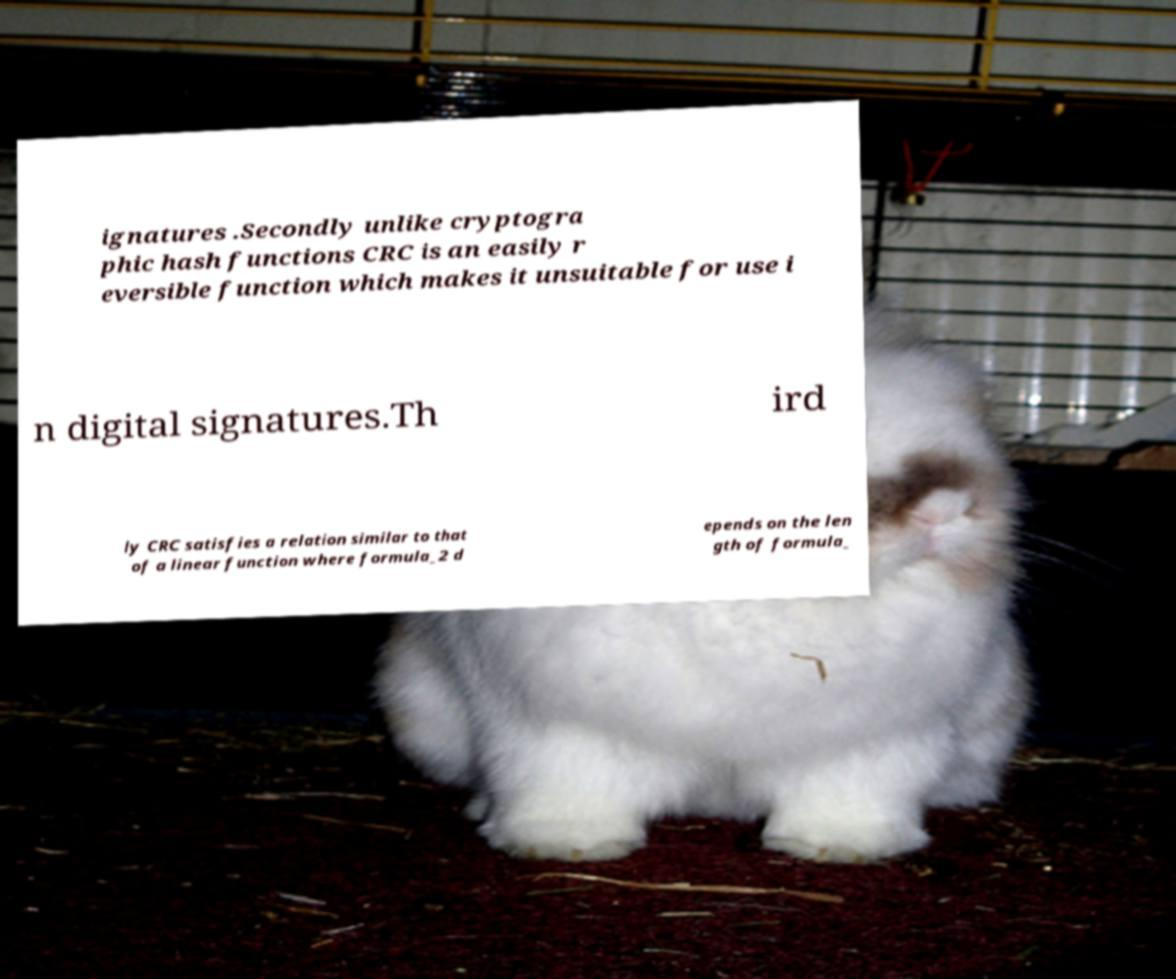There's text embedded in this image that I need extracted. Can you transcribe it verbatim? ignatures .Secondly unlike cryptogra phic hash functions CRC is an easily r eversible function which makes it unsuitable for use i n digital signatures.Th ird ly CRC satisfies a relation similar to that of a linear function where formula_2 d epends on the len gth of formula_ 